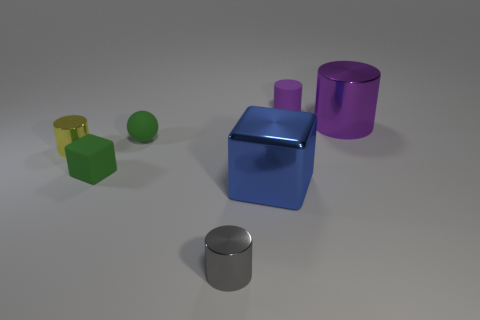There is a small thing that is the same color as the big cylinder; what material is it?
Your response must be concise. Rubber. How many tiny objects are either cylinders or green rubber balls?
Your answer should be very brief. 4. Are there fewer yellow things than tiny yellow rubber balls?
Ensure brevity in your answer.  No. Do the big cylinder and the rubber cylinder have the same color?
Your answer should be very brief. Yes. Are there more yellow metallic objects than purple rubber cubes?
Offer a terse response. Yes. What number of other things are the same color as the big cylinder?
Make the answer very short. 1. What number of purple cylinders are in front of the thing in front of the blue metal thing?
Your response must be concise. 0. Are there any blue cubes behind the blue cube?
Offer a very short reply. No. What is the shape of the small rubber thing on the right side of the big blue block in front of the tiny yellow thing?
Make the answer very short. Cylinder. Is the number of small yellow shiny cylinders on the right side of the blue shiny cube less than the number of tiny objects that are on the left side of the small gray thing?
Offer a terse response. Yes. 